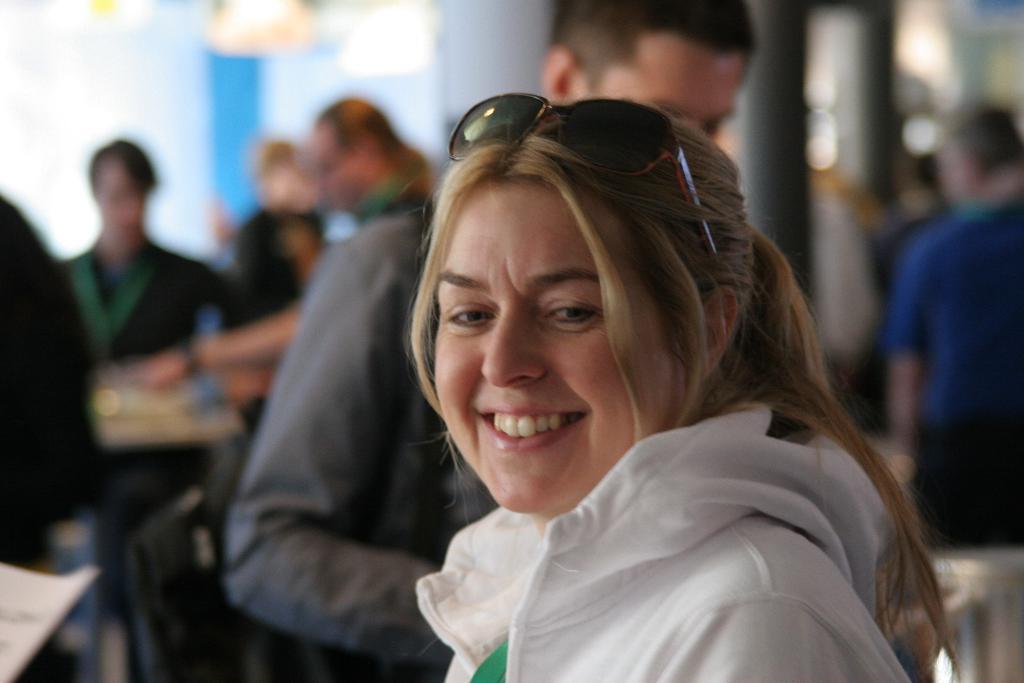Could you give a brief overview of what you see in this image? This picture describes about group of people, in the middle of the image we can see a woman, she is smiling, and we can see spectacles. 